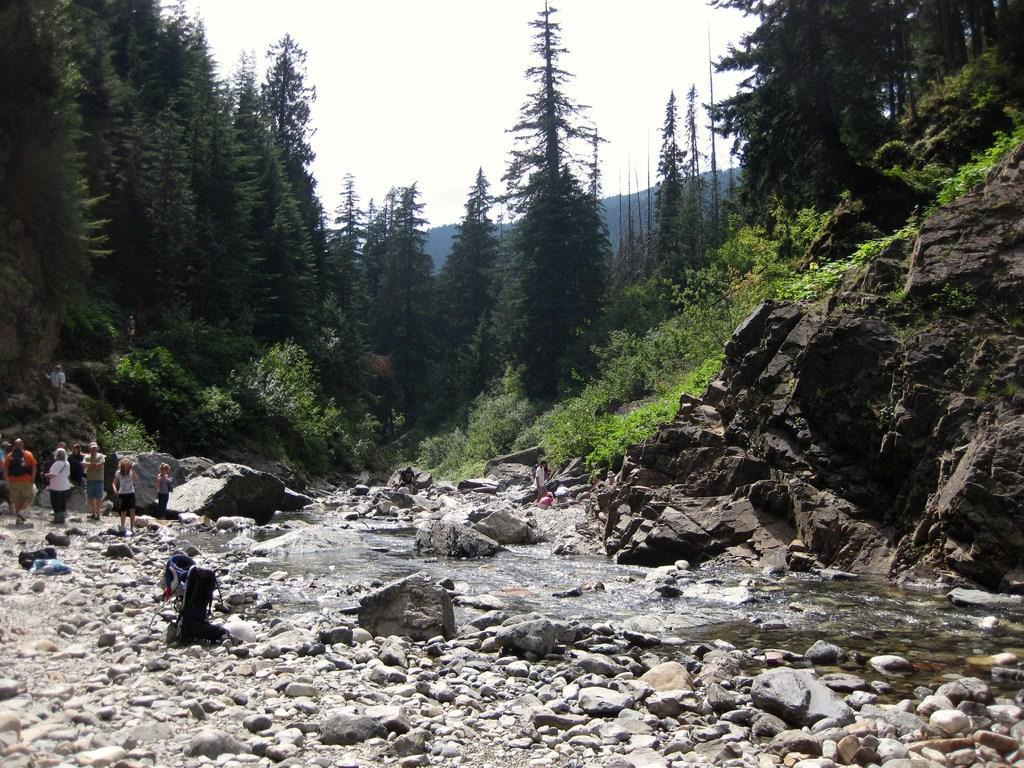Can you describe this image briefly? In this picture I can observe some people standing on the land on the left side. In the middle of the picture I can observe water and rocks. In the background there are trees and sky. 